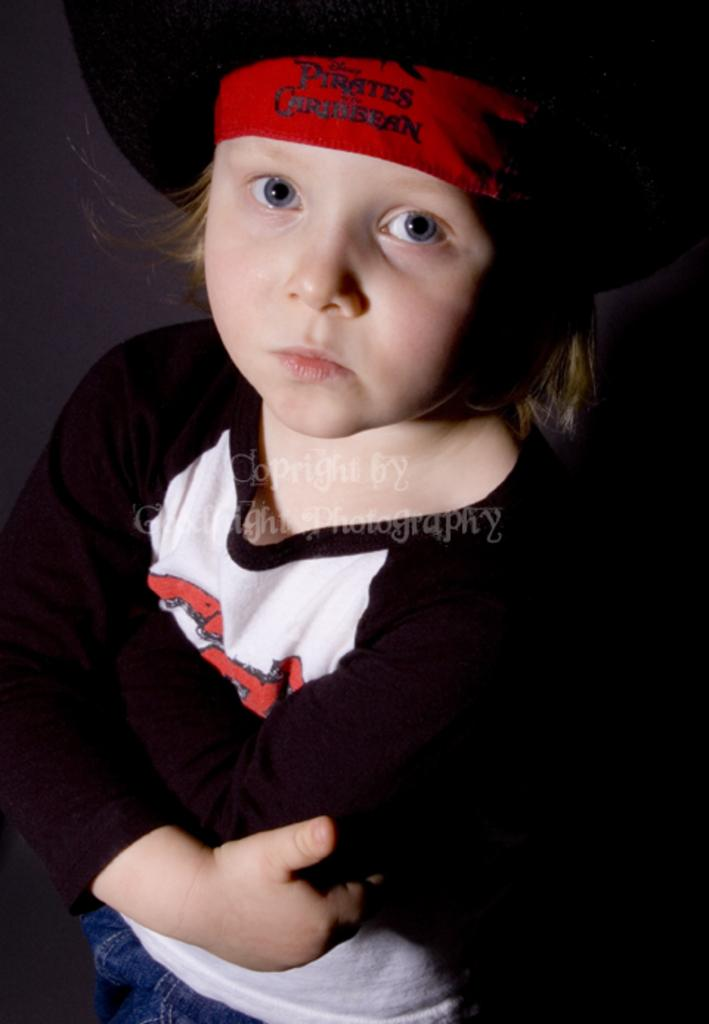Who is the main subject in the image? There is a child in the image. What is the child wearing? The child is wearing a black and white colored dress and a black and red colored hat. What is the child doing in the image? The child is standing. What is the color of the background in the image? The background of the image is black in color. What type of account does the child have in the image? There is no mention of an account in the image, as it features a child wearing a dress and hat while standing against a black background. 